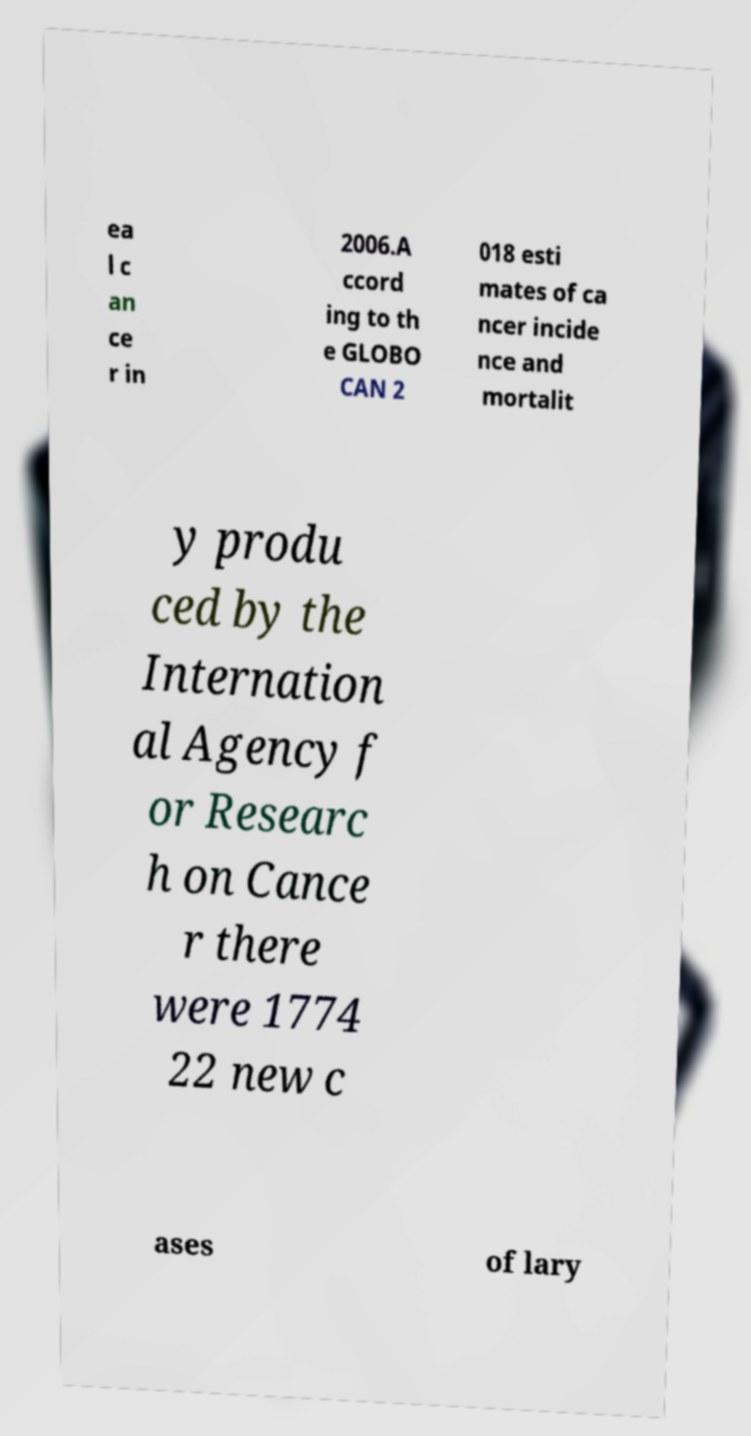Can you accurately transcribe the text from the provided image for me? ea l c an ce r in 2006.A ccord ing to th e GLOBO CAN 2 018 esti mates of ca ncer incide nce and mortalit y produ ced by the Internation al Agency f or Researc h on Cance r there were 1774 22 new c ases of lary 